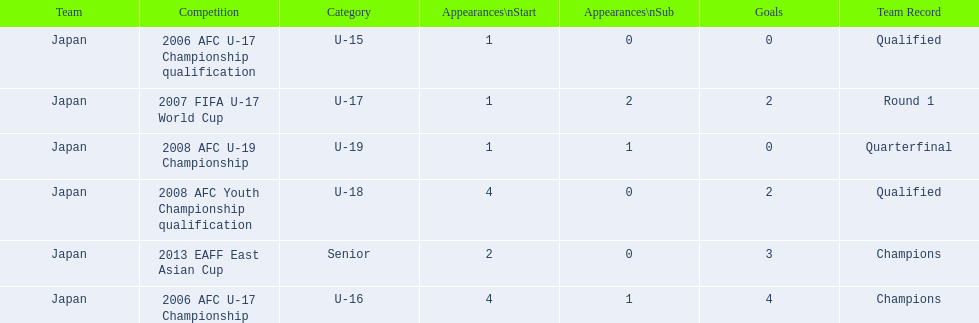Where did japan only score four goals? 2006 AFC U-17 Championship. 